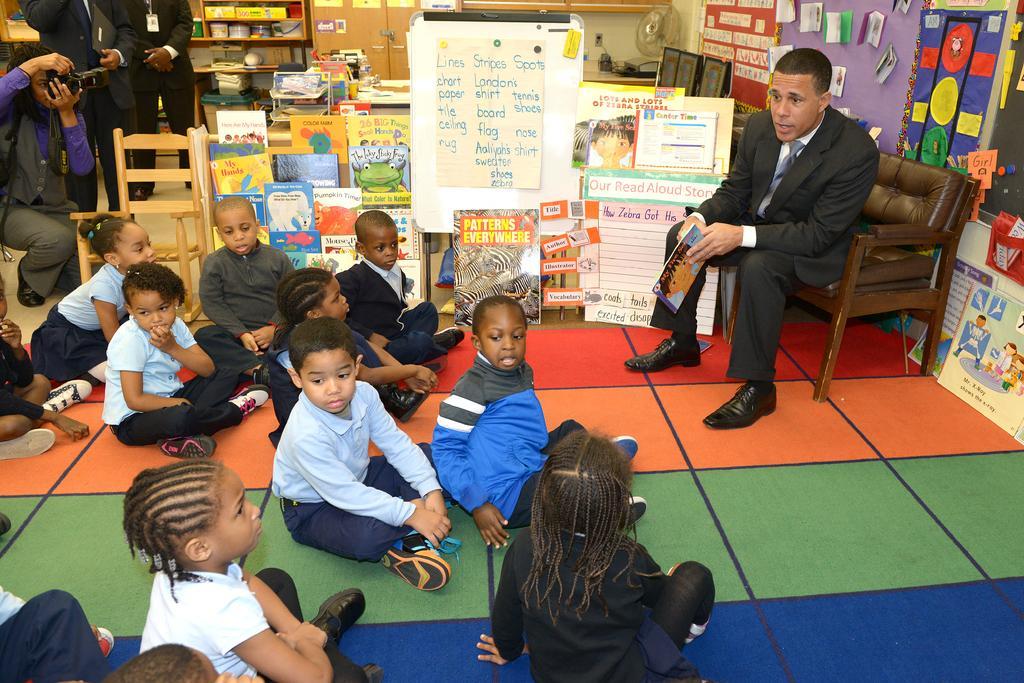In one or two sentences, can you explain what this image depicts? In this image I can see the group of children sitting on the floor. There is a person sitting on the chair and holding the book. To the right of that person there are many boards and papers attached to the wall. I can see the person holding the camera and there are many objects in the cupboard. 